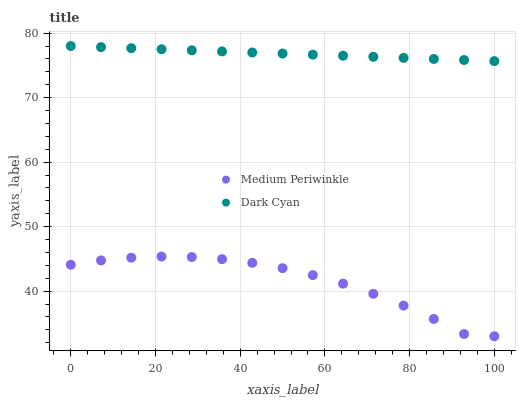Does Medium Periwinkle have the minimum area under the curve?
Answer yes or no. Yes. Does Dark Cyan have the maximum area under the curve?
Answer yes or no. Yes. Does Medium Periwinkle have the maximum area under the curve?
Answer yes or no. No. Is Dark Cyan the smoothest?
Answer yes or no. Yes. Is Medium Periwinkle the roughest?
Answer yes or no. Yes. Is Medium Periwinkle the smoothest?
Answer yes or no. No. Does Medium Periwinkle have the lowest value?
Answer yes or no. Yes. Does Dark Cyan have the highest value?
Answer yes or no. Yes. Does Medium Periwinkle have the highest value?
Answer yes or no. No. Is Medium Periwinkle less than Dark Cyan?
Answer yes or no. Yes. Is Dark Cyan greater than Medium Periwinkle?
Answer yes or no. Yes. Does Medium Periwinkle intersect Dark Cyan?
Answer yes or no. No. 